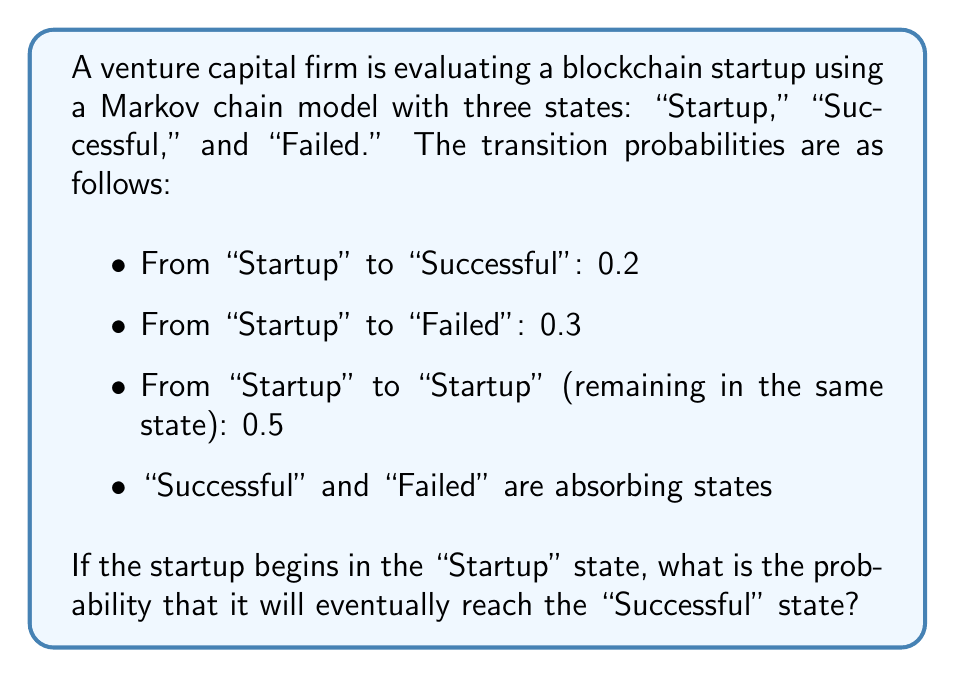Teach me how to tackle this problem. To solve this problem, we'll use the absorbing Markov chain approach:

1) First, let's define our transition matrix P:

   $$P = \begin{bmatrix}
   0.5 & 0.2 & 0.3 \\
   0 & 1 & 0 \\
   0 & 0 & 1
   \end{bmatrix}$$

   Where the states are ordered as Startup, Successful, Failed.

2) In an absorbing Markov chain, we can partition P into:

   $$P = \begin{bmatrix}
   Q & R \\
   0 & I
   \end{bmatrix}$$

   Where Q represents transitions between non-absorbing states, R represents transitions from non-absorbing to absorbing states, and I is the identity matrix for absorbing states.

3) In this case:

   $$Q = [0.5]$$
   $$R = [0.2 \quad 0.3]$$

4) The fundamental matrix N is given by:

   $$N = (I - Q)^{-1}$$

   $$N = (1 - 0.5)^{-1} = 2$$

5) The probability of absorption into each absorbing state is given by:

   $$B = NR$$

   $$B = 2 \times [0.2 \quad 0.3] = [0.4 \quad 0.6]$$

6) The first element of B (0.4) represents the probability of eventually reaching the "Successful" state from the "Startup" state.
Answer: 0.4 